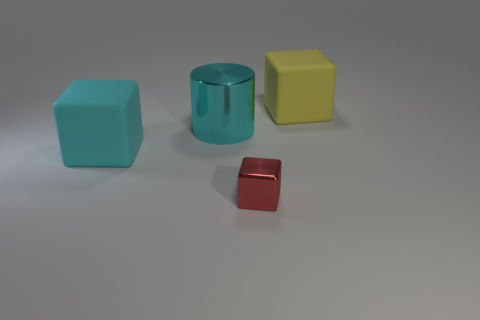Add 4 cyan cylinders. How many objects exist? 8 Subtract all cylinders. How many objects are left? 3 Subtract 1 cyan blocks. How many objects are left? 3 Subtract all small gray metal blocks. Subtract all metallic things. How many objects are left? 2 Add 2 tiny shiny blocks. How many tiny shiny blocks are left? 3 Add 2 large cyan matte objects. How many large cyan matte objects exist? 3 